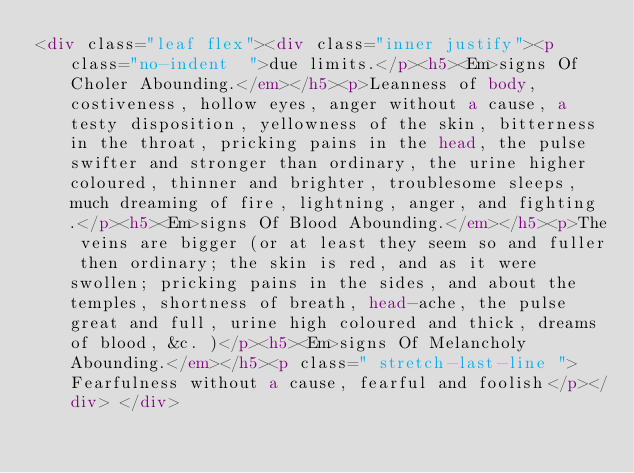Convert code to text. <code><loc_0><loc_0><loc_500><loc_500><_HTML_><div class="leaf flex"><div class="inner justify"><p class="no-indent  ">due limits.</p><h5><Em>signs Of Choler Abounding.</em></h5><p>Leanness of body, costiveness, hollow eyes, anger without a cause, a testy disposition, yellowness of the skin, bitterness in the throat, pricking pains in the head, the pulse swifter and stronger than ordinary, the urine higher coloured, thinner and brighter, troublesome sleeps, much dreaming of fire, lightning, anger, and fighting.</p><h5><Em>signs Of Blood Abounding.</em></h5><p>The veins are bigger (or at least they seem so and fuller then ordinary; the skin is red, and as it were swollen; pricking pains in the sides, and about the temples, shortness of breath, head-ache, the pulse great and full, urine high coloured and thick, dreams of blood, &c. )</p><h5><Em>signs Of Melancholy Abounding.</em></h5><p class=" stretch-last-line ">Fearfulness without a cause, fearful and foolish</p></div> </div></code> 